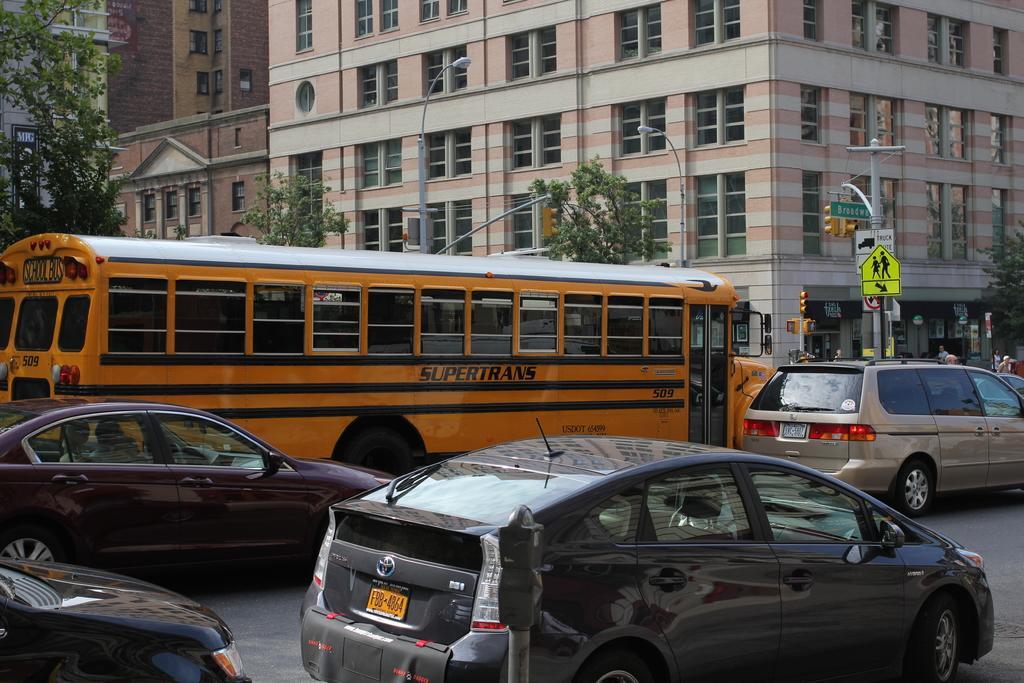In one or two sentences, can you explain what this image depicts? In this image we can see some vehicles moving on the road, at the foreground of the image there is parking token machine and at the background of the image there are some buildings and trees. 